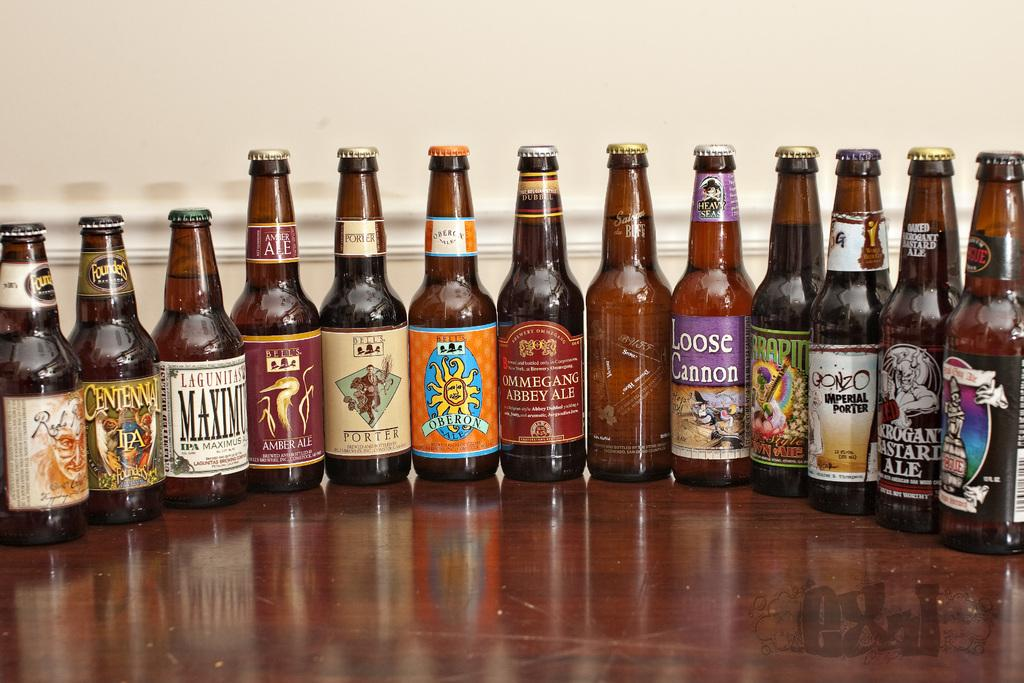<image>
Give a short and clear explanation of the subsequent image. A selection of beers on a table, including IPAs, porters, and ales. 